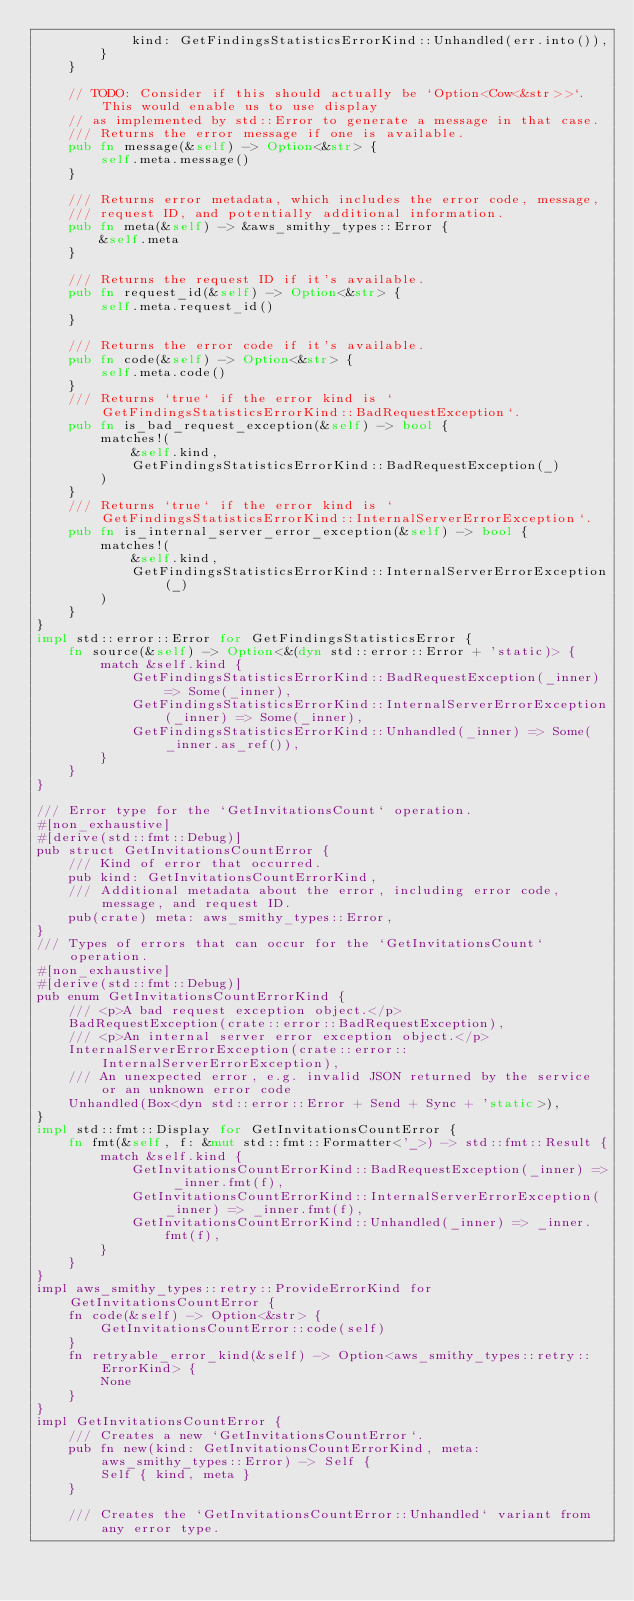<code> <loc_0><loc_0><loc_500><loc_500><_Rust_>            kind: GetFindingsStatisticsErrorKind::Unhandled(err.into()),
        }
    }

    // TODO: Consider if this should actually be `Option<Cow<&str>>`. This would enable us to use display
    // as implemented by std::Error to generate a message in that case.
    /// Returns the error message if one is available.
    pub fn message(&self) -> Option<&str> {
        self.meta.message()
    }

    /// Returns error metadata, which includes the error code, message,
    /// request ID, and potentially additional information.
    pub fn meta(&self) -> &aws_smithy_types::Error {
        &self.meta
    }

    /// Returns the request ID if it's available.
    pub fn request_id(&self) -> Option<&str> {
        self.meta.request_id()
    }

    /// Returns the error code if it's available.
    pub fn code(&self) -> Option<&str> {
        self.meta.code()
    }
    /// Returns `true` if the error kind is `GetFindingsStatisticsErrorKind::BadRequestException`.
    pub fn is_bad_request_exception(&self) -> bool {
        matches!(
            &self.kind,
            GetFindingsStatisticsErrorKind::BadRequestException(_)
        )
    }
    /// Returns `true` if the error kind is `GetFindingsStatisticsErrorKind::InternalServerErrorException`.
    pub fn is_internal_server_error_exception(&self) -> bool {
        matches!(
            &self.kind,
            GetFindingsStatisticsErrorKind::InternalServerErrorException(_)
        )
    }
}
impl std::error::Error for GetFindingsStatisticsError {
    fn source(&self) -> Option<&(dyn std::error::Error + 'static)> {
        match &self.kind {
            GetFindingsStatisticsErrorKind::BadRequestException(_inner) => Some(_inner),
            GetFindingsStatisticsErrorKind::InternalServerErrorException(_inner) => Some(_inner),
            GetFindingsStatisticsErrorKind::Unhandled(_inner) => Some(_inner.as_ref()),
        }
    }
}

/// Error type for the `GetInvitationsCount` operation.
#[non_exhaustive]
#[derive(std::fmt::Debug)]
pub struct GetInvitationsCountError {
    /// Kind of error that occurred.
    pub kind: GetInvitationsCountErrorKind,
    /// Additional metadata about the error, including error code, message, and request ID.
    pub(crate) meta: aws_smithy_types::Error,
}
/// Types of errors that can occur for the `GetInvitationsCount` operation.
#[non_exhaustive]
#[derive(std::fmt::Debug)]
pub enum GetInvitationsCountErrorKind {
    /// <p>A bad request exception object.</p>
    BadRequestException(crate::error::BadRequestException),
    /// <p>An internal server error exception object.</p>
    InternalServerErrorException(crate::error::InternalServerErrorException),
    /// An unexpected error, e.g. invalid JSON returned by the service or an unknown error code
    Unhandled(Box<dyn std::error::Error + Send + Sync + 'static>),
}
impl std::fmt::Display for GetInvitationsCountError {
    fn fmt(&self, f: &mut std::fmt::Formatter<'_>) -> std::fmt::Result {
        match &self.kind {
            GetInvitationsCountErrorKind::BadRequestException(_inner) => _inner.fmt(f),
            GetInvitationsCountErrorKind::InternalServerErrorException(_inner) => _inner.fmt(f),
            GetInvitationsCountErrorKind::Unhandled(_inner) => _inner.fmt(f),
        }
    }
}
impl aws_smithy_types::retry::ProvideErrorKind for GetInvitationsCountError {
    fn code(&self) -> Option<&str> {
        GetInvitationsCountError::code(self)
    }
    fn retryable_error_kind(&self) -> Option<aws_smithy_types::retry::ErrorKind> {
        None
    }
}
impl GetInvitationsCountError {
    /// Creates a new `GetInvitationsCountError`.
    pub fn new(kind: GetInvitationsCountErrorKind, meta: aws_smithy_types::Error) -> Self {
        Self { kind, meta }
    }

    /// Creates the `GetInvitationsCountError::Unhandled` variant from any error type.</code> 